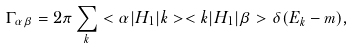Convert formula to latex. <formula><loc_0><loc_0><loc_500><loc_500>\Gamma _ { \alpha \beta } = 2 \pi \sum _ { k } < \alpha | H _ { 1 } | k > < k | H _ { 1 } | \beta > \delta ( E _ { k } - m ) ,</formula> 